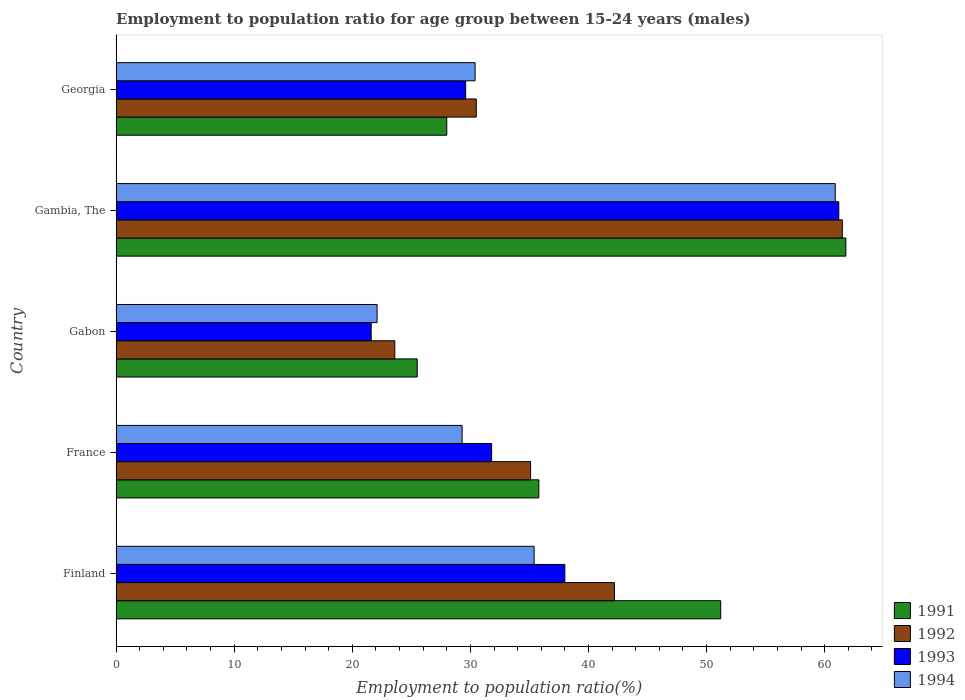Are the number of bars per tick equal to the number of legend labels?
Provide a succinct answer. Yes. How many bars are there on the 1st tick from the bottom?
Your answer should be very brief. 4. In how many cases, is the number of bars for a given country not equal to the number of legend labels?
Make the answer very short. 0. What is the employment to population ratio in 1994 in Finland?
Keep it short and to the point. 35.4. Across all countries, what is the maximum employment to population ratio in 1992?
Offer a terse response. 61.5. Across all countries, what is the minimum employment to population ratio in 1994?
Your answer should be very brief. 22.1. In which country was the employment to population ratio in 1992 maximum?
Your answer should be very brief. Gambia, The. In which country was the employment to population ratio in 1992 minimum?
Offer a very short reply. Gabon. What is the total employment to population ratio in 1994 in the graph?
Provide a short and direct response. 178.1. What is the difference between the employment to population ratio in 1994 in Gambia, The and that in Georgia?
Keep it short and to the point. 30.5. What is the difference between the employment to population ratio in 1994 in France and the employment to population ratio in 1992 in Gabon?
Provide a succinct answer. 5.7. What is the average employment to population ratio in 1994 per country?
Provide a short and direct response. 35.62. What is the difference between the employment to population ratio in 1992 and employment to population ratio in 1991 in Gambia, The?
Ensure brevity in your answer.  -0.3. What is the ratio of the employment to population ratio in 1992 in France to that in Gambia, The?
Keep it short and to the point. 0.57. Is the employment to population ratio in 1992 in Gambia, The less than that in Georgia?
Your response must be concise. No. What is the difference between the highest and the second highest employment to population ratio in 1994?
Ensure brevity in your answer.  25.5. What is the difference between the highest and the lowest employment to population ratio in 1992?
Your answer should be very brief. 37.9. What does the 3rd bar from the bottom in Georgia represents?
Keep it short and to the point. 1993. How many countries are there in the graph?
Your response must be concise. 5. Does the graph contain any zero values?
Provide a succinct answer. No. How are the legend labels stacked?
Keep it short and to the point. Vertical. What is the title of the graph?
Provide a succinct answer. Employment to population ratio for age group between 15-24 years (males). What is the label or title of the Y-axis?
Give a very brief answer. Country. What is the Employment to population ratio(%) in 1991 in Finland?
Ensure brevity in your answer.  51.2. What is the Employment to population ratio(%) in 1992 in Finland?
Make the answer very short. 42.2. What is the Employment to population ratio(%) of 1993 in Finland?
Your answer should be very brief. 38. What is the Employment to population ratio(%) of 1994 in Finland?
Your response must be concise. 35.4. What is the Employment to population ratio(%) of 1991 in France?
Give a very brief answer. 35.8. What is the Employment to population ratio(%) in 1992 in France?
Give a very brief answer. 35.1. What is the Employment to population ratio(%) of 1993 in France?
Provide a succinct answer. 31.8. What is the Employment to population ratio(%) in 1994 in France?
Offer a terse response. 29.3. What is the Employment to population ratio(%) in 1991 in Gabon?
Your answer should be compact. 25.5. What is the Employment to population ratio(%) of 1992 in Gabon?
Provide a short and direct response. 23.6. What is the Employment to population ratio(%) of 1993 in Gabon?
Your answer should be compact. 21.6. What is the Employment to population ratio(%) in 1994 in Gabon?
Make the answer very short. 22.1. What is the Employment to population ratio(%) of 1991 in Gambia, The?
Ensure brevity in your answer.  61.8. What is the Employment to population ratio(%) of 1992 in Gambia, The?
Provide a succinct answer. 61.5. What is the Employment to population ratio(%) in 1993 in Gambia, The?
Keep it short and to the point. 61.2. What is the Employment to population ratio(%) in 1994 in Gambia, The?
Offer a terse response. 60.9. What is the Employment to population ratio(%) in 1992 in Georgia?
Make the answer very short. 30.5. What is the Employment to population ratio(%) in 1993 in Georgia?
Provide a succinct answer. 29.6. What is the Employment to population ratio(%) of 1994 in Georgia?
Your response must be concise. 30.4. Across all countries, what is the maximum Employment to population ratio(%) in 1991?
Keep it short and to the point. 61.8. Across all countries, what is the maximum Employment to population ratio(%) of 1992?
Your answer should be very brief. 61.5. Across all countries, what is the maximum Employment to population ratio(%) in 1993?
Offer a terse response. 61.2. Across all countries, what is the maximum Employment to population ratio(%) in 1994?
Your answer should be very brief. 60.9. Across all countries, what is the minimum Employment to population ratio(%) of 1992?
Give a very brief answer. 23.6. Across all countries, what is the minimum Employment to population ratio(%) of 1993?
Your response must be concise. 21.6. Across all countries, what is the minimum Employment to population ratio(%) in 1994?
Ensure brevity in your answer.  22.1. What is the total Employment to population ratio(%) of 1991 in the graph?
Provide a succinct answer. 202.3. What is the total Employment to population ratio(%) in 1992 in the graph?
Provide a succinct answer. 192.9. What is the total Employment to population ratio(%) in 1993 in the graph?
Provide a succinct answer. 182.2. What is the total Employment to population ratio(%) in 1994 in the graph?
Make the answer very short. 178.1. What is the difference between the Employment to population ratio(%) of 1991 in Finland and that in France?
Give a very brief answer. 15.4. What is the difference between the Employment to population ratio(%) in 1992 in Finland and that in France?
Provide a short and direct response. 7.1. What is the difference between the Employment to population ratio(%) in 1993 in Finland and that in France?
Your answer should be very brief. 6.2. What is the difference between the Employment to population ratio(%) of 1991 in Finland and that in Gabon?
Your answer should be very brief. 25.7. What is the difference between the Employment to population ratio(%) in 1992 in Finland and that in Gabon?
Offer a very short reply. 18.6. What is the difference between the Employment to population ratio(%) in 1994 in Finland and that in Gabon?
Offer a very short reply. 13.3. What is the difference between the Employment to population ratio(%) of 1992 in Finland and that in Gambia, The?
Your answer should be very brief. -19.3. What is the difference between the Employment to population ratio(%) in 1993 in Finland and that in Gambia, The?
Your response must be concise. -23.2. What is the difference between the Employment to population ratio(%) of 1994 in Finland and that in Gambia, The?
Your answer should be very brief. -25.5. What is the difference between the Employment to population ratio(%) in 1991 in Finland and that in Georgia?
Your answer should be compact. 23.2. What is the difference between the Employment to population ratio(%) in 1992 in Finland and that in Georgia?
Offer a terse response. 11.7. What is the difference between the Employment to population ratio(%) of 1993 in Finland and that in Georgia?
Make the answer very short. 8.4. What is the difference between the Employment to population ratio(%) of 1992 in France and that in Gabon?
Provide a short and direct response. 11.5. What is the difference between the Employment to population ratio(%) in 1993 in France and that in Gabon?
Give a very brief answer. 10.2. What is the difference between the Employment to population ratio(%) of 1994 in France and that in Gabon?
Give a very brief answer. 7.2. What is the difference between the Employment to population ratio(%) in 1991 in France and that in Gambia, The?
Offer a very short reply. -26. What is the difference between the Employment to population ratio(%) of 1992 in France and that in Gambia, The?
Your answer should be compact. -26.4. What is the difference between the Employment to population ratio(%) in 1993 in France and that in Gambia, The?
Provide a succinct answer. -29.4. What is the difference between the Employment to population ratio(%) of 1994 in France and that in Gambia, The?
Your response must be concise. -31.6. What is the difference between the Employment to population ratio(%) of 1991 in France and that in Georgia?
Your response must be concise. 7.8. What is the difference between the Employment to population ratio(%) in 1994 in France and that in Georgia?
Keep it short and to the point. -1.1. What is the difference between the Employment to population ratio(%) of 1991 in Gabon and that in Gambia, The?
Give a very brief answer. -36.3. What is the difference between the Employment to population ratio(%) in 1992 in Gabon and that in Gambia, The?
Offer a terse response. -37.9. What is the difference between the Employment to population ratio(%) of 1993 in Gabon and that in Gambia, The?
Offer a terse response. -39.6. What is the difference between the Employment to population ratio(%) in 1994 in Gabon and that in Gambia, The?
Give a very brief answer. -38.8. What is the difference between the Employment to population ratio(%) in 1992 in Gabon and that in Georgia?
Ensure brevity in your answer.  -6.9. What is the difference between the Employment to population ratio(%) in 1991 in Gambia, The and that in Georgia?
Your answer should be compact. 33.8. What is the difference between the Employment to population ratio(%) of 1993 in Gambia, The and that in Georgia?
Provide a short and direct response. 31.6. What is the difference between the Employment to population ratio(%) of 1994 in Gambia, The and that in Georgia?
Provide a short and direct response. 30.5. What is the difference between the Employment to population ratio(%) of 1991 in Finland and the Employment to population ratio(%) of 1992 in France?
Your answer should be compact. 16.1. What is the difference between the Employment to population ratio(%) of 1991 in Finland and the Employment to population ratio(%) of 1993 in France?
Your response must be concise. 19.4. What is the difference between the Employment to population ratio(%) in 1991 in Finland and the Employment to population ratio(%) in 1994 in France?
Offer a terse response. 21.9. What is the difference between the Employment to population ratio(%) of 1992 in Finland and the Employment to population ratio(%) of 1993 in France?
Ensure brevity in your answer.  10.4. What is the difference between the Employment to population ratio(%) of 1992 in Finland and the Employment to population ratio(%) of 1994 in France?
Provide a succinct answer. 12.9. What is the difference between the Employment to population ratio(%) of 1991 in Finland and the Employment to population ratio(%) of 1992 in Gabon?
Offer a very short reply. 27.6. What is the difference between the Employment to population ratio(%) of 1991 in Finland and the Employment to population ratio(%) of 1993 in Gabon?
Ensure brevity in your answer.  29.6. What is the difference between the Employment to population ratio(%) of 1991 in Finland and the Employment to population ratio(%) of 1994 in Gabon?
Make the answer very short. 29.1. What is the difference between the Employment to population ratio(%) of 1992 in Finland and the Employment to population ratio(%) of 1993 in Gabon?
Keep it short and to the point. 20.6. What is the difference between the Employment to population ratio(%) in 1992 in Finland and the Employment to population ratio(%) in 1994 in Gabon?
Keep it short and to the point. 20.1. What is the difference between the Employment to population ratio(%) of 1991 in Finland and the Employment to population ratio(%) of 1992 in Gambia, The?
Provide a short and direct response. -10.3. What is the difference between the Employment to population ratio(%) of 1991 in Finland and the Employment to population ratio(%) of 1993 in Gambia, The?
Your response must be concise. -10. What is the difference between the Employment to population ratio(%) in 1992 in Finland and the Employment to population ratio(%) in 1993 in Gambia, The?
Keep it short and to the point. -19. What is the difference between the Employment to population ratio(%) of 1992 in Finland and the Employment to population ratio(%) of 1994 in Gambia, The?
Your answer should be compact. -18.7. What is the difference between the Employment to population ratio(%) in 1993 in Finland and the Employment to population ratio(%) in 1994 in Gambia, The?
Provide a succinct answer. -22.9. What is the difference between the Employment to population ratio(%) in 1991 in Finland and the Employment to population ratio(%) in 1992 in Georgia?
Give a very brief answer. 20.7. What is the difference between the Employment to population ratio(%) of 1991 in Finland and the Employment to population ratio(%) of 1993 in Georgia?
Give a very brief answer. 21.6. What is the difference between the Employment to population ratio(%) of 1991 in Finland and the Employment to population ratio(%) of 1994 in Georgia?
Your response must be concise. 20.8. What is the difference between the Employment to population ratio(%) of 1992 in Finland and the Employment to population ratio(%) of 1993 in Georgia?
Provide a short and direct response. 12.6. What is the difference between the Employment to population ratio(%) of 1992 in Finland and the Employment to population ratio(%) of 1994 in Georgia?
Your response must be concise. 11.8. What is the difference between the Employment to population ratio(%) in 1991 in France and the Employment to population ratio(%) in 1992 in Gabon?
Your response must be concise. 12.2. What is the difference between the Employment to population ratio(%) in 1991 in France and the Employment to population ratio(%) in 1994 in Gabon?
Your response must be concise. 13.7. What is the difference between the Employment to population ratio(%) in 1992 in France and the Employment to population ratio(%) in 1994 in Gabon?
Keep it short and to the point. 13. What is the difference between the Employment to population ratio(%) in 1993 in France and the Employment to population ratio(%) in 1994 in Gabon?
Give a very brief answer. 9.7. What is the difference between the Employment to population ratio(%) in 1991 in France and the Employment to population ratio(%) in 1992 in Gambia, The?
Ensure brevity in your answer.  -25.7. What is the difference between the Employment to population ratio(%) in 1991 in France and the Employment to population ratio(%) in 1993 in Gambia, The?
Offer a very short reply. -25.4. What is the difference between the Employment to population ratio(%) of 1991 in France and the Employment to population ratio(%) of 1994 in Gambia, The?
Your answer should be compact. -25.1. What is the difference between the Employment to population ratio(%) in 1992 in France and the Employment to population ratio(%) in 1993 in Gambia, The?
Make the answer very short. -26.1. What is the difference between the Employment to population ratio(%) in 1992 in France and the Employment to population ratio(%) in 1994 in Gambia, The?
Provide a short and direct response. -25.8. What is the difference between the Employment to population ratio(%) in 1993 in France and the Employment to population ratio(%) in 1994 in Gambia, The?
Keep it short and to the point. -29.1. What is the difference between the Employment to population ratio(%) in 1991 in France and the Employment to population ratio(%) in 1992 in Georgia?
Provide a short and direct response. 5.3. What is the difference between the Employment to population ratio(%) in 1991 in France and the Employment to population ratio(%) in 1993 in Georgia?
Provide a short and direct response. 6.2. What is the difference between the Employment to population ratio(%) in 1992 in France and the Employment to population ratio(%) in 1993 in Georgia?
Offer a terse response. 5.5. What is the difference between the Employment to population ratio(%) in 1991 in Gabon and the Employment to population ratio(%) in 1992 in Gambia, The?
Give a very brief answer. -36. What is the difference between the Employment to population ratio(%) of 1991 in Gabon and the Employment to population ratio(%) of 1993 in Gambia, The?
Keep it short and to the point. -35.7. What is the difference between the Employment to population ratio(%) of 1991 in Gabon and the Employment to population ratio(%) of 1994 in Gambia, The?
Offer a terse response. -35.4. What is the difference between the Employment to population ratio(%) of 1992 in Gabon and the Employment to population ratio(%) of 1993 in Gambia, The?
Your answer should be compact. -37.6. What is the difference between the Employment to population ratio(%) in 1992 in Gabon and the Employment to population ratio(%) in 1994 in Gambia, The?
Your answer should be compact. -37.3. What is the difference between the Employment to population ratio(%) of 1993 in Gabon and the Employment to population ratio(%) of 1994 in Gambia, The?
Keep it short and to the point. -39.3. What is the difference between the Employment to population ratio(%) of 1991 in Gabon and the Employment to population ratio(%) of 1992 in Georgia?
Keep it short and to the point. -5. What is the difference between the Employment to population ratio(%) in 1991 in Gabon and the Employment to population ratio(%) in 1993 in Georgia?
Your response must be concise. -4.1. What is the difference between the Employment to population ratio(%) in 1992 in Gabon and the Employment to population ratio(%) in 1993 in Georgia?
Provide a succinct answer. -6. What is the difference between the Employment to population ratio(%) in 1991 in Gambia, The and the Employment to population ratio(%) in 1992 in Georgia?
Provide a short and direct response. 31.3. What is the difference between the Employment to population ratio(%) in 1991 in Gambia, The and the Employment to population ratio(%) in 1993 in Georgia?
Ensure brevity in your answer.  32.2. What is the difference between the Employment to population ratio(%) in 1991 in Gambia, The and the Employment to population ratio(%) in 1994 in Georgia?
Provide a succinct answer. 31.4. What is the difference between the Employment to population ratio(%) in 1992 in Gambia, The and the Employment to population ratio(%) in 1993 in Georgia?
Your answer should be very brief. 31.9. What is the difference between the Employment to population ratio(%) in 1992 in Gambia, The and the Employment to population ratio(%) in 1994 in Georgia?
Ensure brevity in your answer.  31.1. What is the difference between the Employment to population ratio(%) in 1993 in Gambia, The and the Employment to population ratio(%) in 1994 in Georgia?
Keep it short and to the point. 30.8. What is the average Employment to population ratio(%) in 1991 per country?
Offer a terse response. 40.46. What is the average Employment to population ratio(%) in 1992 per country?
Provide a succinct answer. 38.58. What is the average Employment to population ratio(%) in 1993 per country?
Ensure brevity in your answer.  36.44. What is the average Employment to population ratio(%) in 1994 per country?
Offer a very short reply. 35.62. What is the difference between the Employment to population ratio(%) of 1992 and Employment to population ratio(%) of 1993 in Finland?
Give a very brief answer. 4.2. What is the difference between the Employment to population ratio(%) of 1993 and Employment to population ratio(%) of 1994 in Finland?
Provide a short and direct response. 2.6. What is the difference between the Employment to population ratio(%) of 1991 and Employment to population ratio(%) of 1993 in France?
Keep it short and to the point. 4. What is the difference between the Employment to population ratio(%) in 1992 and Employment to population ratio(%) in 1994 in France?
Your response must be concise. 5.8. What is the difference between the Employment to population ratio(%) of 1993 and Employment to population ratio(%) of 1994 in France?
Provide a succinct answer. 2.5. What is the difference between the Employment to population ratio(%) of 1991 and Employment to population ratio(%) of 1994 in Gabon?
Your response must be concise. 3.4. What is the difference between the Employment to population ratio(%) in 1992 and Employment to population ratio(%) in 1993 in Gabon?
Ensure brevity in your answer.  2. What is the difference between the Employment to population ratio(%) in 1993 and Employment to population ratio(%) in 1994 in Gabon?
Offer a very short reply. -0.5. What is the difference between the Employment to population ratio(%) in 1992 and Employment to population ratio(%) in 1993 in Gambia, The?
Keep it short and to the point. 0.3. What is the difference between the Employment to population ratio(%) of 1992 and Employment to population ratio(%) of 1994 in Gambia, The?
Provide a short and direct response. 0.6. What is the difference between the Employment to population ratio(%) in 1992 and Employment to population ratio(%) in 1994 in Georgia?
Provide a succinct answer. 0.1. What is the ratio of the Employment to population ratio(%) in 1991 in Finland to that in France?
Your response must be concise. 1.43. What is the ratio of the Employment to population ratio(%) of 1992 in Finland to that in France?
Give a very brief answer. 1.2. What is the ratio of the Employment to population ratio(%) in 1993 in Finland to that in France?
Provide a succinct answer. 1.2. What is the ratio of the Employment to population ratio(%) of 1994 in Finland to that in France?
Keep it short and to the point. 1.21. What is the ratio of the Employment to population ratio(%) of 1991 in Finland to that in Gabon?
Your answer should be very brief. 2.01. What is the ratio of the Employment to population ratio(%) of 1992 in Finland to that in Gabon?
Your response must be concise. 1.79. What is the ratio of the Employment to population ratio(%) in 1993 in Finland to that in Gabon?
Your response must be concise. 1.76. What is the ratio of the Employment to population ratio(%) of 1994 in Finland to that in Gabon?
Provide a succinct answer. 1.6. What is the ratio of the Employment to population ratio(%) in 1991 in Finland to that in Gambia, The?
Offer a terse response. 0.83. What is the ratio of the Employment to population ratio(%) in 1992 in Finland to that in Gambia, The?
Give a very brief answer. 0.69. What is the ratio of the Employment to population ratio(%) of 1993 in Finland to that in Gambia, The?
Ensure brevity in your answer.  0.62. What is the ratio of the Employment to population ratio(%) of 1994 in Finland to that in Gambia, The?
Offer a very short reply. 0.58. What is the ratio of the Employment to population ratio(%) in 1991 in Finland to that in Georgia?
Your answer should be compact. 1.83. What is the ratio of the Employment to population ratio(%) in 1992 in Finland to that in Georgia?
Your answer should be compact. 1.38. What is the ratio of the Employment to population ratio(%) in 1993 in Finland to that in Georgia?
Your answer should be compact. 1.28. What is the ratio of the Employment to population ratio(%) of 1994 in Finland to that in Georgia?
Provide a short and direct response. 1.16. What is the ratio of the Employment to population ratio(%) in 1991 in France to that in Gabon?
Provide a succinct answer. 1.4. What is the ratio of the Employment to population ratio(%) of 1992 in France to that in Gabon?
Keep it short and to the point. 1.49. What is the ratio of the Employment to population ratio(%) of 1993 in France to that in Gabon?
Give a very brief answer. 1.47. What is the ratio of the Employment to population ratio(%) of 1994 in France to that in Gabon?
Keep it short and to the point. 1.33. What is the ratio of the Employment to population ratio(%) in 1991 in France to that in Gambia, The?
Provide a short and direct response. 0.58. What is the ratio of the Employment to population ratio(%) in 1992 in France to that in Gambia, The?
Your answer should be very brief. 0.57. What is the ratio of the Employment to population ratio(%) in 1993 in France to that in Gambia, The?
Offer a very short reply. 0.52. What is the ratio of the Employment to population ratio(%) of 1994 in France to that in Gambia, The?
Offer a terse response. 0.48. What is the ratio of the Employment to population ratio(%) of 1991 in France to that in Georgia?
Your response must be concise. 1.28. What is the ratio of the Employment to population ratio(%) of 1992 in France to that in Georgia?
Offer a very short reply. 1.15. What is the ratio of the Employment to population ratio(%) of 1993 in France to that in Georgia?
Provide a short and direct response. 1.07. What is the ratio of the Employment to population ratio(%) in 1994 in France to that in Georgia?
Offer a very short reply. 0.96. What is the ratio of the Employment to population ratio(%) of 1991 in Gabon to that in Gambia, The?
Make the answer very short. 0.41. What is the ratio of the Employment to population ratio(%) of 1992 in Gabon to that in Gambia, The?
Offer a very short reply. 0.38. What is the ratio of the Employment to population ratio(%) in 1993 in Gabon to that in Gambia, The?
Give a very brief answer. 0.35. What is the ratio of the Employment to population ratio(%) of 1994 in Gabon to that in Gambia, The?
Keep it short and to the point. 0.36. What is the ratio of the Employment to population ratio(%) in 1991 in Gabon to that in Georgia?
Your answer should be very brief. 0.91. What is the ratio of the Employment to population ratio(%) of 1992 in Gabon to that in Georgia?
Offer a very short reply. 0.77. What is the ratio of the Employment to population ratio(%) in 1993 in Gabon to that in Georgia?
Offer a very short reply. 0.73. What is the ratio of the Employment to population ratio(%) of 1994 in Gabon to that in Georgia?
Keep it short and to the point. 0.73. What is the ratio of the Employment to population ratio(%) in 1991 in Gambia, The to that in Georgia?
Ensure brevity in your answer.  2.21. What is the ratio of the Employment to population ratio(%) in 1992 in Gambia, The to that in Georgia?
Offer a terse response. 2.02. What is the ratio of the Employment to population ratio(%) in 1993 in Gambia, The to that in Georgia?
Your response must be concise. 2.07. What is the ratio of the Employment to population ratio(%) in 1994 in Gambia, The to that in Georgia?
Give a very brief answer. 2. What is the difference between the highest and the second highest Employment to population ratio(%) of 1992?
Give a very brief answer. 19.3. What is the difference between the highest and the second highest Employment to population ratio(%) in 1993?
Provide a succinct answer. 23.2. What is the difference between the highest and the lowest Employment to population ratio(%) of 1991?
Provide a short and direct response. 36.3. What is the difference between the highest and the lowest Employment to population ratio(%) in 1992?
Your answer should be very brief. 37.9. What is the difference between the highest and the lowest Employment to population ratio(%) of 1993?
Provide a succinct answer. 39.6. What is the difference between the highest and the lowest Employment to population ratio(%) of 1994?
Keep it short and to the point. 38.8. 